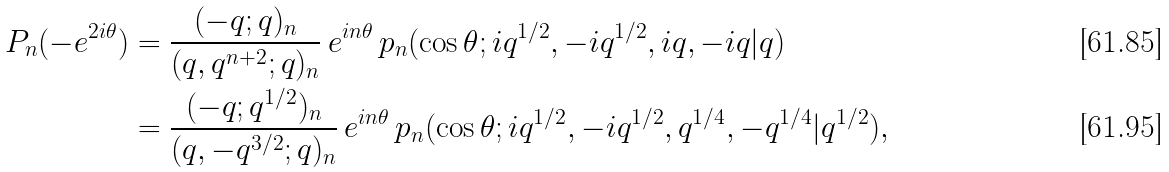Convert formula to latex. <formula><loc_0><loc_0><loc_500><loc_500>P _ { n } ( - e ^ { 2 i \theta } ) & = \frac { ( - q ; q ) _ { n } } { ( q , q ^ { n + 2 } ; q ) _ { n } } \, e ^ { i n \theta } \, p _ { n } ( \cos \theta ; i q ^ { 1 / 2 } , - i q ^ { 1 / 2 } , i q , - i q | q ) \\ & = \frac { ( - q ; q ^ { 1 / 2 } ) _ { n } } { ( q , - q ^ { 3 / 2 } ; q ) _ { n } } \, e ^ { i n \theta } \, p _ { n } ( \cos \theta ; i q ^ { 1 / 2 } , - i q ^ { 1 / 2 } , q ^ { 1 / 4 } , - q ^ { 1 / 4 } | q ^ { 1 / 2 } ) ,</formula> 